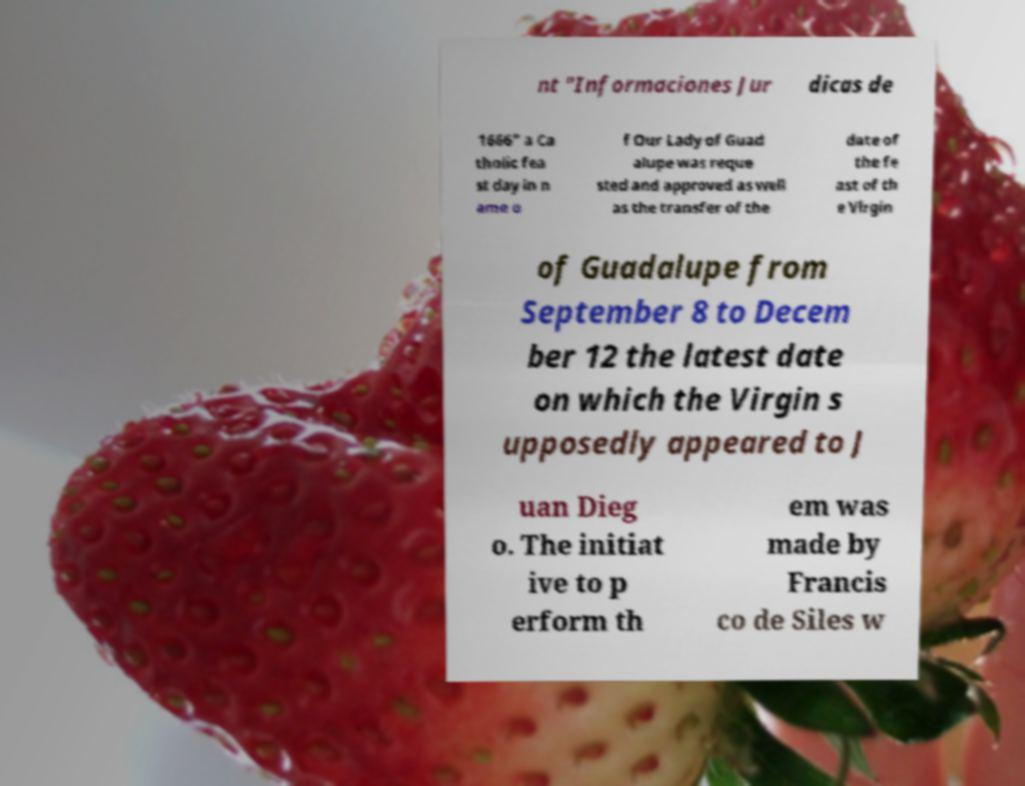For documentation purposes, I need the text within this image transcribed. Could you provide that? nt "Informaciones Jur dicas de 1666" a Ca tholic fea st day in n ame o f Our Lady of Guad alupe was reque sted and approved as well as the transfer of the date of the fe ast of th e Virgin of Guadalupe from September 8 to Decem ber 12 the latest date on which the Virgin s upposedly appeared to J uan Dieg o. The initiat ive to p erform th em was made by Francis co de Siles w 